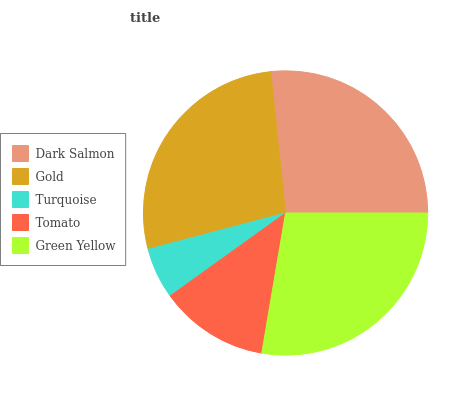Is Turquoise the minimum?
Answer yes or no. Yes. Is Green Yellow the maximum?
Answer yes or no. Yes. Is Gold the minimum?
Answer yes or no. No. Is Gold the maximum?
Answer yes or no. No. Is Gold greater than Dark Salmon?
Answer yes or no. Yes. Is Dark Salmon less than Gold?
Answer yes or no. Yes. Is Dark Salmon greater than Gold?
Answer yes or no. No. Is Gold less than Dark Salmon?
Answer yes or no. No. Is Dark Salmon the high median?
Answer yes or no. Yes. Is Dark Salmon the low median?
Answer yes or no. Yes. Is Turquoise the high median?
Answer yes or no. No. Is Green Yellow the low median?
Answer yes or no. No. 